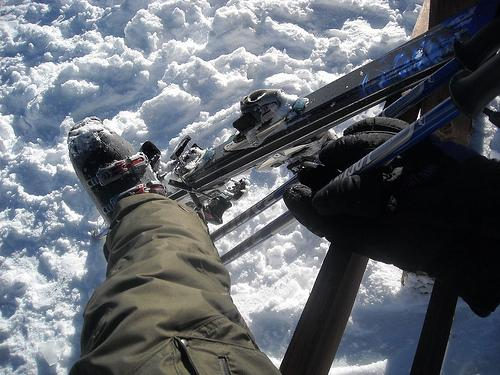Please provide a brief description of the scene depicted in this image. The image shows an outdoor winter scene with various skiing equipment and a person wearing puffy olive pants, surrounded by clumps of white snow. Analyze the sentiment of the image based on the objects and scene present. The image evokes a cold and adventurous sentiment as it showcases an outdoor winter scene with skiing equipment and snowy surroundings. Can you analyze the interaction of the person wearing puffy olive pants with their surroundings? The person is likely engaged in skiing, standing in the snow amongst their skiing equipment like skis, skiing pole, and snow-covered boots. Identify any objects related to snow in the image and their count. Clump of white snow (10), boot with snow on it (1), skis with snow on them (1), and ski boot caked in snow (1). What is the most distinctive feature of the ski shown in the image? The ski has a blue design and a locking mechanism. List all the objects related to skiing present in the image. Skis with snow on them, ski boot with snow, skiing pole with black handle, locking mechanism on ski, and ski with blue design. Can you tell me how many clumps of white snow are present in the image? There are 10 clumps of white snow in the image. How would you describe the features of the skiing pole found in the image? with black handle Find an object in the image that cannot be recognized by OCR. ski boot caked in snow Based on the image, what is the most likely weather during this event? snowy, cold What is the color and design of the ski in this image? blue design Look for a pair of pants with a gold button at X:155 Y:320 width a width of 72 and a height of 72, can you see them? The pants in the image have a silver button, not a gold button as mentioned in the instruction. Describe the texture of the snow found in the image. broken up, clumps What is the color of the pants found in this image and what is their feature? olive colored, puffy Can you find the clump of white snow at X:255 Y:2 with a width of 100 and a height of 100? The actual width and height of the clump of white snow at X:255 Y:2 are 65 and 65, not 100 and 100 as mentioned in the instruction. What is the unique feature of the ski boot found in the image? caked in snow What is the overall theme or setting of this image? outdoors scene Is there a yellow boot with snow on it at X:44 Y:113 width a width of 108 and a height of 108? The boot in the image is described as having snow on it, but there is no mention of it being yellow. The boot's main attributes are red latches and snow on it. Identify the color of the latches on the boot. red Considering the objects present, create a sentence to describe this scene. A snowy outdoor scene with a skier wearing olive puffy pants and large black gloves. How many large black gloves are present in the image? 2 Given the scene, select the right caption to describe it: (1) A house interior with a fireplace and chair, (2) A skiing scene with snowy objects and gear A skiing scene with snowy objects and gear Can you spot a skiing pole with a blue handle at X:422 Y:36 width a width of 72 and a height of 72? The skiing pole has a black handle, not a blue handle as mentioned in the instruction. Are there 3 large black gloves at X:303 Y:119 width a width of 182 and a height of 182? There are only 2 large black gloves, not 3 as mentioned in the instruction. Identify two activities a person could be doing in this scene. skiing, walking through snow Based on the diagram, what is the most prominent activity taking place? skiing List three prominent objects that you can link to an outdoor skiing scene. skis with snow, skiing pole, snow Is there any emphasized emotion in this image? no Can you find skis with red design at X:326 Y:45 width a width of 160 and a height of 160? The ski in the image has a blue design, not a red design as mentioned in the instruction. What object can be found at the top left corner of the image? clump of white snow What items of clothing is the skier wearing in this image? pants, gloves 